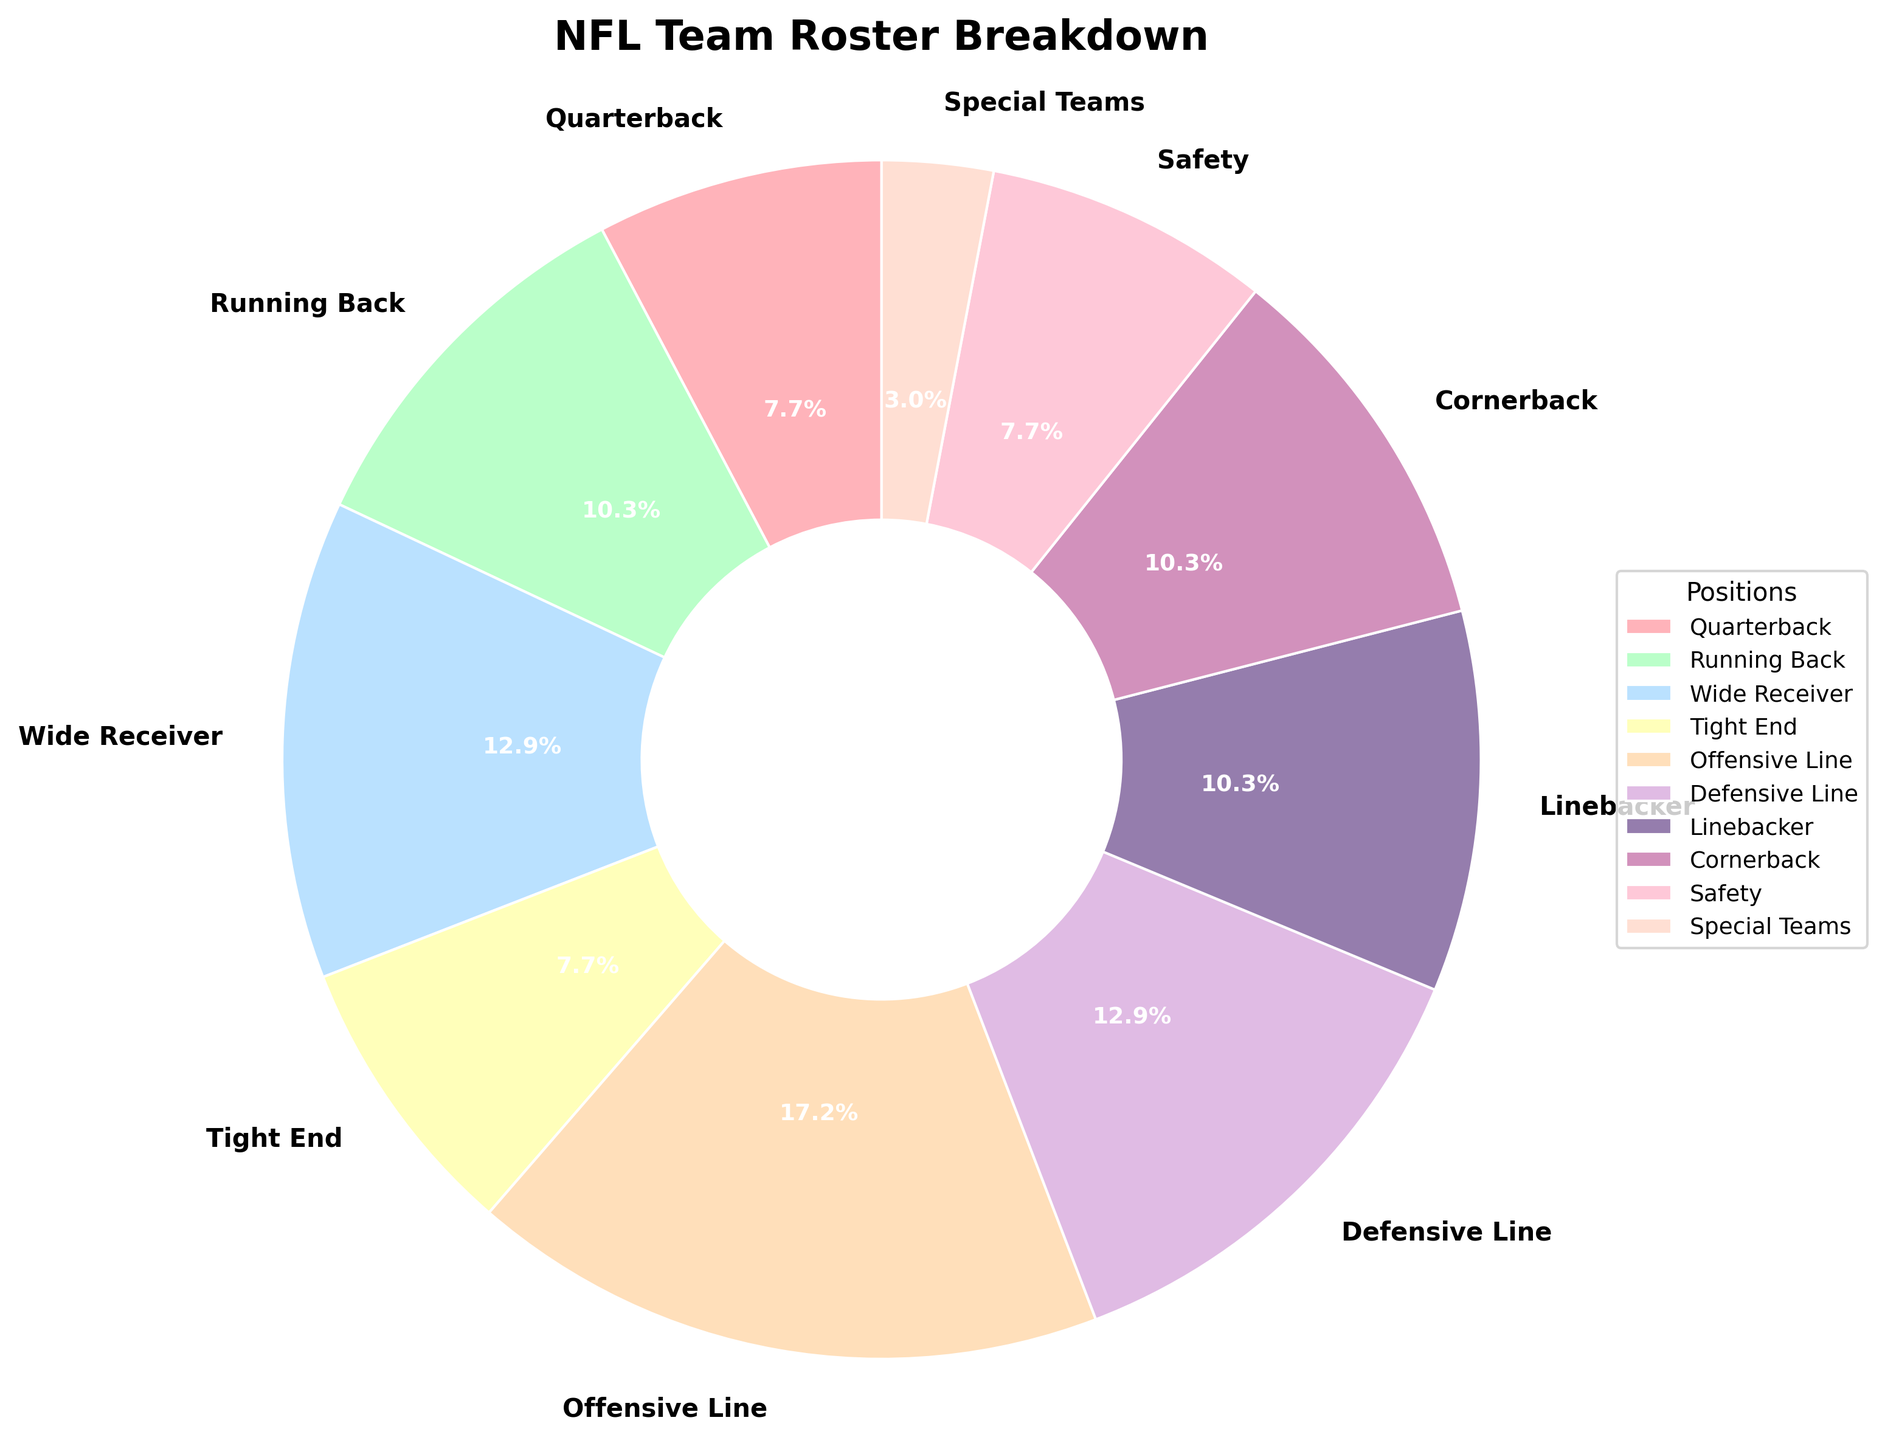Which position has the highest percentage on the NFL team roster breakdown? By referring to the segments in the pie chart, the largest segment represents the Offensive Line position.
Answer: Offensive Line What's the combined percentage of Wide Receivers and Defensive Line on the NFL team roster breakdown? The pie chart shows the percentages for Wide Receivers (14.2%) and Defensive Line (14.2%). Adding these gives 14.2 + 14.2.
Answer: 28.4% Does the Special Teams position have less percentage than Linebackers? In the pie chart, the percentage for Special Teams is 3.3%, which is less than the 11.3% for Linebackers.
Answer: Yes What's the difference in percentage between the Running Back and Cornerback positions? According to the pie chart, both Running Back and Cornerback have a percentage of 11.3%. Therefore, the difference is 0%.
Answer: 0% What color represents the Defensive Line segment on the pie chart? Observing the pie chart colors, the Defensive Line segment is shown in a shade of blue.
Answer: Blue Which positions share the same percentage in the NFL team roster breakdown? By examining the pie chart, the Quarterback, Tight End, and Safety positions all have an equal percentage of 8.5%.
Answer: Quarterback, Tight End, Safety How does the percentage of the Offensive Line compare to the combined percentage of Quarterback and Running Back? The chart shows that the Offensive Line has a percentage of 18.9%. The combined percentage for Quarterback (8.5%) and Running Back (11.3%) is 8.5 + 11.3 = 19.8%, which is greater than 18.9%.
Answer: Less What is the average percentage of the Defensive Line, Linebacker, and Cornerback positions? The percentages are 14.2% (Defensive Line), 11.3% (Linebacker), and 11.3% (Cornerback). Adding these gives a total of 36.8%. Dividing by 3 gives 36.8 / 3.
Answer: 12.27% Which position is represented by a green color slice on the pie chart? Observing the colored segments, the Running Back position is denoted by a green color.
Answer: Running Back Is the percentage of the Safety position greater than the percentage of the Special Teams position? The pie chart shows that the Safety position has 8.5%, which is greater in comparison to the Special Teams position’s 3.3%.
Answer: Yes 